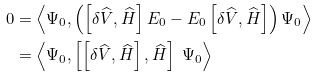Convert formula to latex. <formula><loc_0><loc_0><loc_500><loc_500>0 & = \left \langle \Psi _ { 0 } , \left ( \left [ \delta \widehat { V } , \widehat { H } \right ] E _ { 0 } - E _ { 0 } \left [ \delta \widehat { V } , \widehat { H } \right ] \right ) \Psi _ { 0 } \right \rangle \\ & = \left \langle \Psi _ { 0 } , \left [ \left [ \delta \widehat { V } , \widehat { H } \right ] , \widehat { H } \right ] \ \Psi _ { 0 } \right \rangle</formula> 